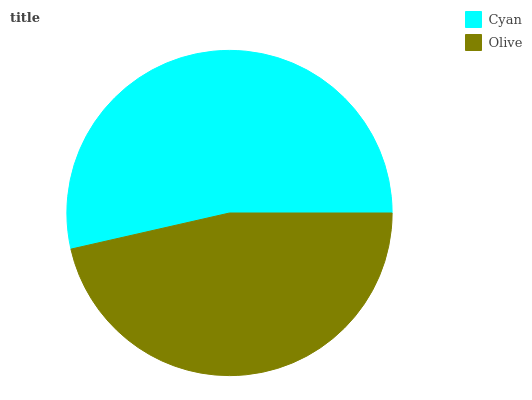Is Olive the minimum?
Answer yes or no. Yes. Is Cyan the maximum?
Answer yes or no. Yes. Is Olive the maximum?
Answer yes or no. No. Is Cyan greater than Olive?
Answer yes or no. Yes. Is Olive less than Cyan?
Answer yes or no. Yes. Is Olive greater than Cyan?
Answer yes or no. No. Is Cyan less than Olive?
Answer yes or no. No. Is Cyan the high median?
Answer yes or no. Yes. Is Olive the low median?
Answer yes or no. Yes. Is Olive the high median?
Answer yes or no. No. Is Cyan the low median?
Answer yes or no. No. 